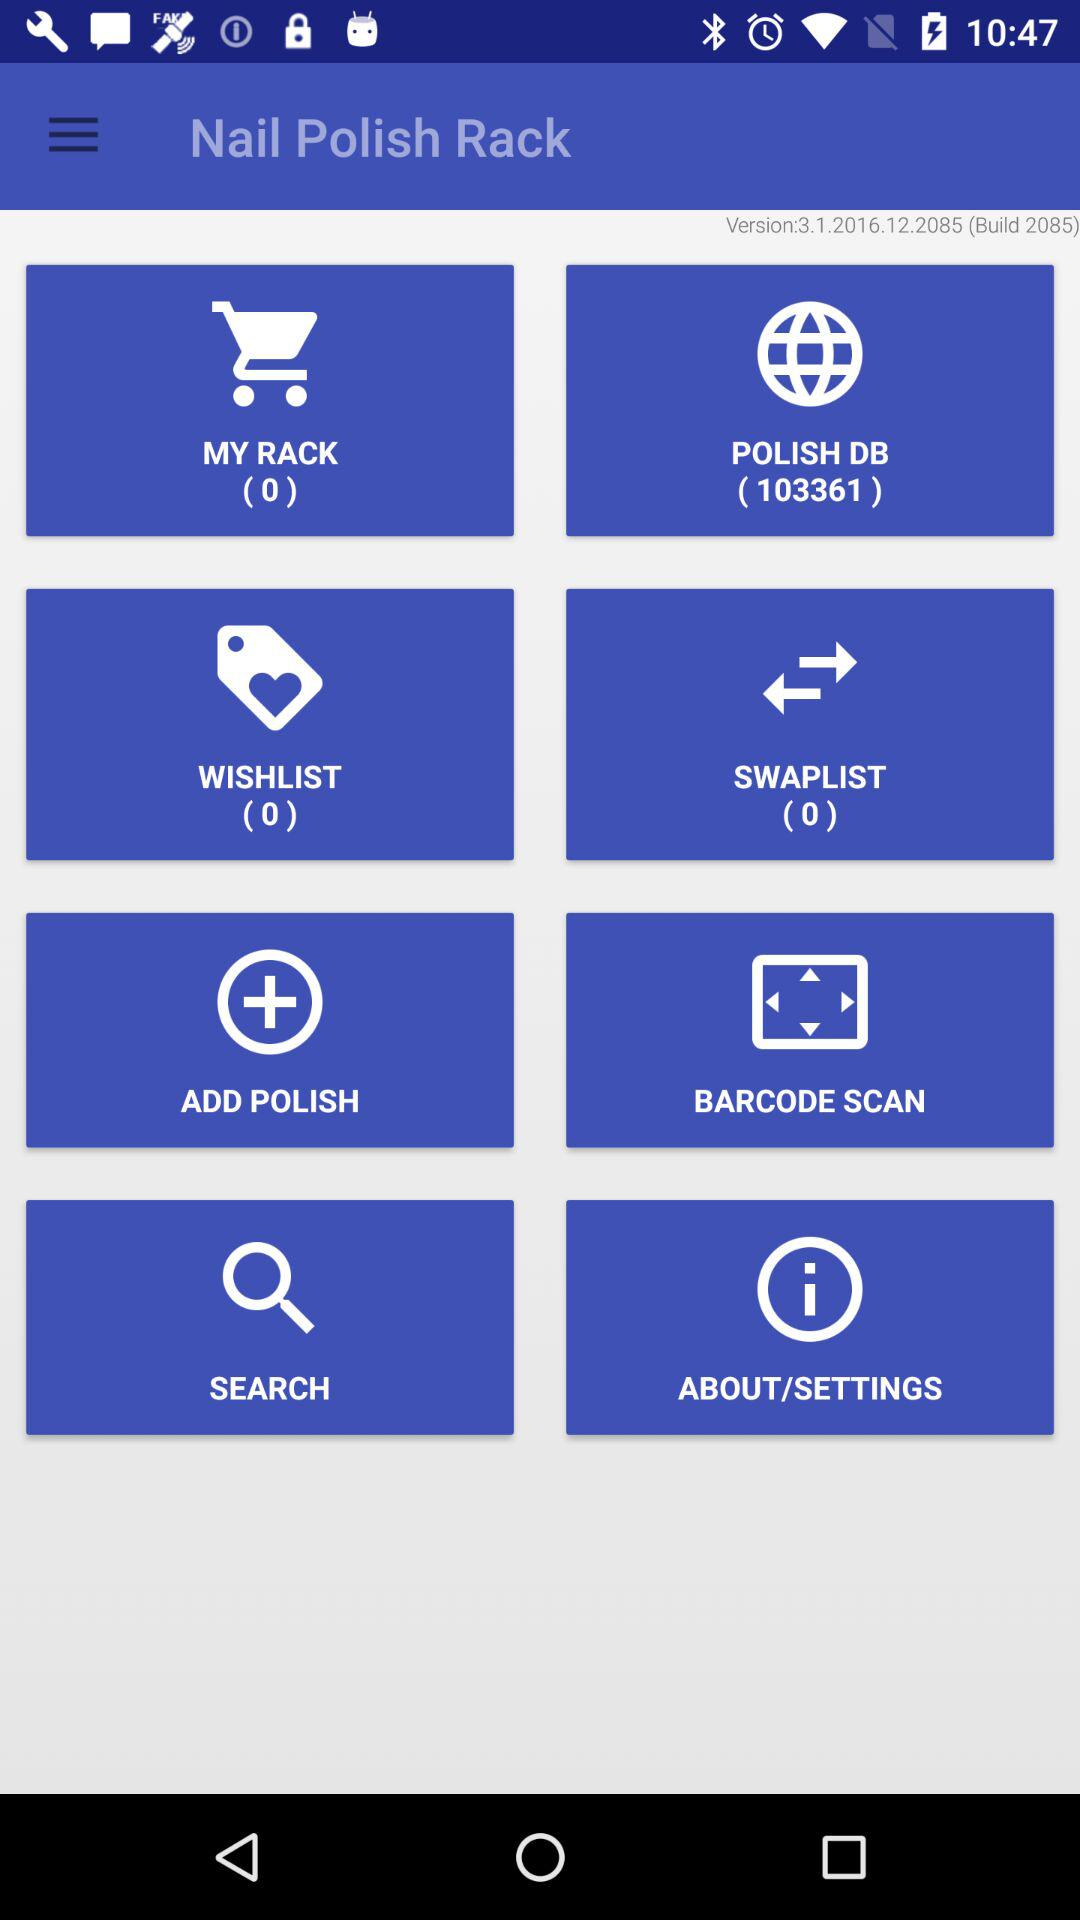What number is showing in the "POLISH DB"? The number is 103361. 